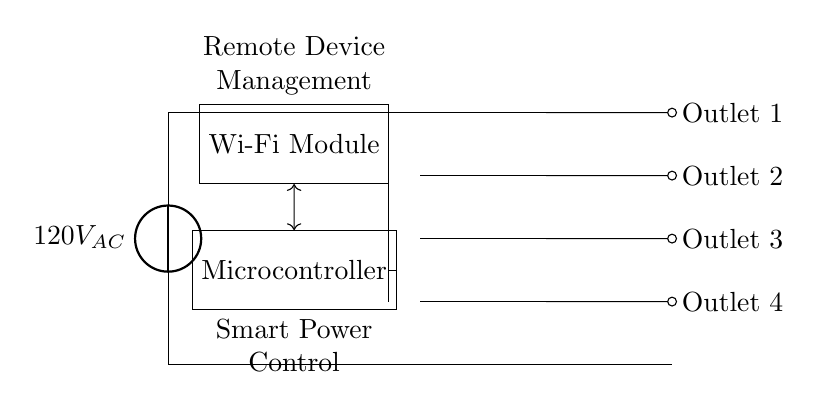What is the source voltage in this circuit? The source voltage is shown as 120 volts AC, indicating the power supplied to the circuit.
Answer: 120V AC What components are used in the circuit? The components include a Wi-Fi module, a microcontroller, relays, and four outlets. Each component serves a specific function in managing the power distribution and connectivity.
Answer: Wi-Fi module, microcontroller, relays, outlets How many outlets are connected to this smart power strip? There are four outlets in total, each labeled sequentially from Outlet 1 to Outlet 4. This configuration allows multiple devices to be connected and managed.
Answer: Four What is the function of the microcontroller in this circuit? The microcontroller is responsible for smart power control, managing the switching of the relays based on the commands received from the Wi-Fi module for remote management.
Answer: Smart power control Which component connects to the Wi-Fi module? The component that connects to the Wi-Fi module is the microcontroller. The connection facilitates the communication between the Wi-Fi module and the microcontroller for remote device management.
Answer: Microcontroller How many relays are present in this circuit? The circuit includes four relays, which are used to control the individual power supply to each outlet, allowing for independent operation.
Answer: Four What type of circuit is represented here? The type of circuit represented is a smart power strip circuit with Wi-Fi connectivity, designed for remote management of household appliances through wired connections.
Answer: Smart power strip circuit 